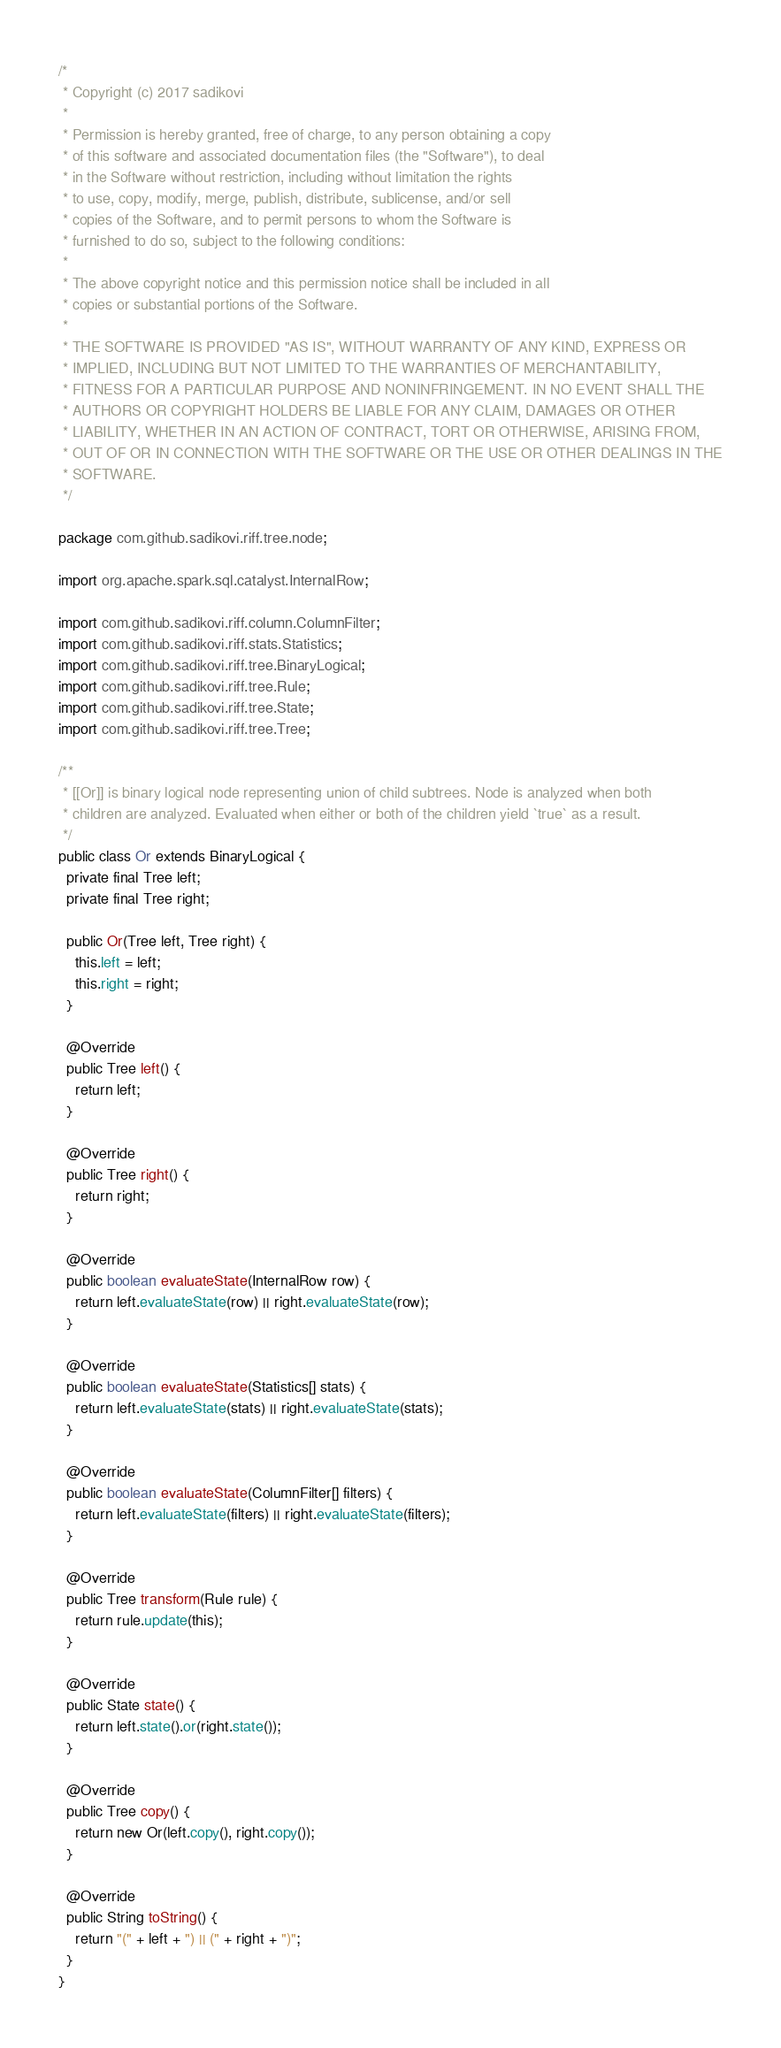Convert code to text. <code><loc_0><loc_0><loc_500><loc_500><_Java_>/*
 * Copyright (c) 2017 sadikovi
 *
 * Permission is hereby granted, free of charge, to any person obtaining a copy
 * of this software and associated documentation files (the "Software"), to deal
 * in the Software without restriction, including without limitation the rights
 * to use, copy, modify, merge, publish, distribute, sublicense, and/or sell
 * copies of the Software, and to permit persons to whom the Software is
 * furnished to do so, subject to the following conditions:
 *
 * The above copyright notice and this permission notice shall be included in all
 * copies or substantial portions of the Software.
 *
 * THE SOFTWARE IS PROVIDED "AS IS", WITHOUT WARRANTY OF ANY KIND, EXPRESS OR
 * IMPLIED, INCLUDING BUT NOT LIMITED TO THE WARRANTIES OF MERCHANTABILITY,
 * FITNESS FOR A PARTICULAR PURPOSE AND NONINFRINGEMENT. IN NO EVENT SHALL THE
 * AUTHORS OR COPYRIGHT HOLDERS BE LIABLE FOR ANY CLAIM, DAMAGES OR OTHER
 * LIABILITY, WHETHER IN AN ACTION OF CONTRACT, TORT OR OTHERWISE, ARISING FROM,
 * OUT OF OR IN CONNECTION WITH THE SOFTWARE OR THE USE OR OTHER DEALINGS IN THE
 * SOFTWARE.
 */

package com.github.sadikovi.riff.tree.node;

import org.apache.spark.sql.catalyst.InternalRow;

import com.github.sadikovi.riff.column.ColumnFilter;
import com.github.sadikovi.riff.stats.Statistics;
import com.github.sadikovi.riff.tree.BinaryLogical;
import com.github.sadikovi.riff.tree.Rule;
import com.github.sadikovi.riff.tree.State;
import com.github.sadikovi.riff.tree.Tree;

/**
 * [[Or]] is binary logical node representing union of child subtrees. Node is analyzed when both
 * children are analyzed. Evaluated when either or both of the children yield `true` as a result.
 */
public class Or extends BinaryLogical {
  private final Tree left;
  private final Tree right;

  public Or(Tree left, Tree right) {
    this.left = left;
    this.right = right;
  }

  @Override
  public Tree left() {
    return left;
  }

  @Override
  public Tree right() {
    return right;
  }

  @Override
  public boolean evaluateState(InternalRow row) {
    return left.evaluateState(row) || right.evaluateState(row);
  }

  @Override
  public boolean evaluateState(Statistics[] stats) {
    return left.evaluateState(stats) || right.evaluateState(stats);
  }

  @Override
  public boolean evaluateState(ColumnFilter[] filters) {
    return left.evaluateState(filters) || right.evaluateState(filters);
  }

  @Override
  public Tree transform(Rule rule) {
    return rule.update(this);
  }

  @Override
  public State state() {
    return left.state().or(right.state());
  }

  @Override
  public Tree copy() {
    return new Or(left.copy(), right.copy());
  }

  @Override
  public String toString() {
    return "(" + left + ") || (" + right + ")";
  }
}
</code> 